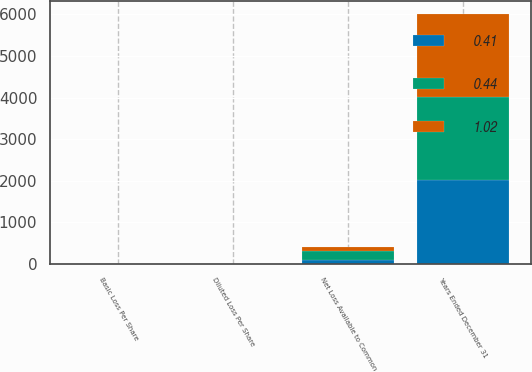Convert chart to OTSL. <chart><loc_0><loc_0><loc_500><loc_500><stacked_bar_chart><ecel><fcel>Years Ended December 31<fcel>Net Loss Available to Common<fcel>Basic Loss Per Share<fcel>Diluted Loss Per Share<nl><fcel>0.44<fcel>2007<fcel>227<fcel>1.02<fcel>1.02<nl><fcel>0.41<fcel>2006<fcel>90<fcel>0.41<fcel>0.41<nl><fcel>1.02<fcel>2005<fcel>94<fcel>0.44<fcel>0.44<nl></chart> 